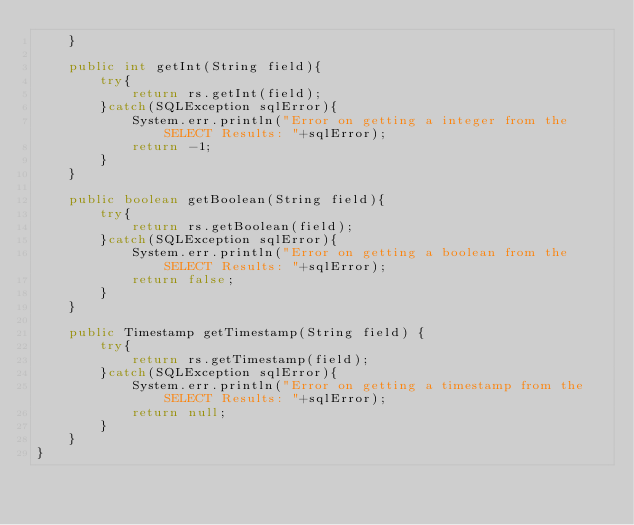<code> <loc_0><loc_0><loc_500><loc_500><_Java_>    }

    public int getInt(String field){
        try{
            return rs.getInt(field);
        }catch(SQLException sqlError){
            System.err.println("Error on getting a integer from the SELECT Results: "+sqlError);
            return -1;
        }
    }

    public boolean getBoolean(String field){
        try{
            return rs.getBoolean(field);
        }catch(SQLException sqlError){
            System.err.println("Error on getting a boolean from the SELECT Results: "+sqlError);
            return false;
        }
    }
    
    public Timestamp getTimestamp(String field) {
        try{
            return rs.getTimestamp(field);
        }catch(SQLException sqlError){
            System.err.println("Error on getting a timestamp from the SELECT Results: "+sqlError);
            return null;
        }
    }
}</code> 